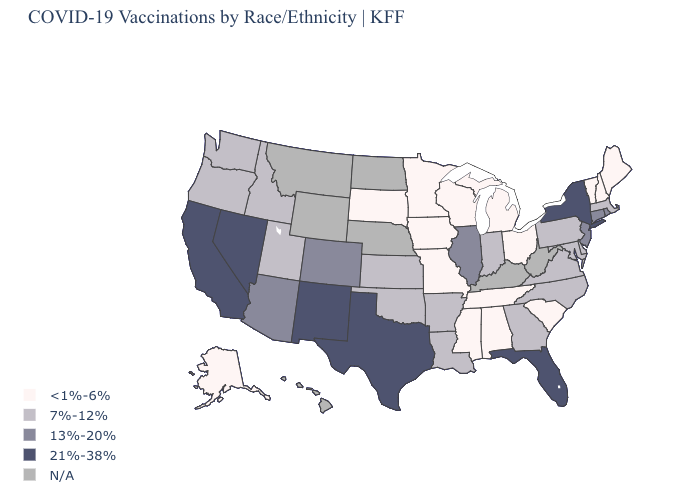What is the lowest value in the Northeast?
Answer briefly. <1%-6%. Name the states that have a value in the range 21%-38%?
Write a very short answer. California, Florida, Nevada, New Mexico, New York, Texas. Is the legend a continuous bar?
Be succinct. No. Among the states that border New York , does Connecticut have the highest value?
Keep it brief. Yes. Among the states that border Arkansas , does Mississippi have the lowest value?
Quick response, please. Yes. Which states have the highest value in the USA?
Give a very brief answer. California, Florida, Nevada, New Mexico, New York, Texas. Name the states that have a value in the range N/A?
Be succinct. Hawaii, Kentucky, Montana, Nebraska, North Dakota, West Virginia, Wyoming. Does Texas have the highest value in the South?
Write a very short answer. Yes. What is the value of Arizona?
Quick response, please. 13%-20%. Among the states that border Kansas , does Colorado have the highest value?
Keep it brief. Yes. Which states have the lowest value in the Northeast?
Keep it brief. Maine, New Hampshire, Vermont. What is the value of Nevada?
Quick response, please. 21%-38%. What is the value of North Dakota?
Give a very brief answer. N/A. Does Nevada have the highest value in the USA?
Quick response, please. Yes. Name the states that have a value in the range 13%-20%?
Short answer required. Arizona, Colorado, Connecticut, Illinois, New Jersey, Rhode Island. 